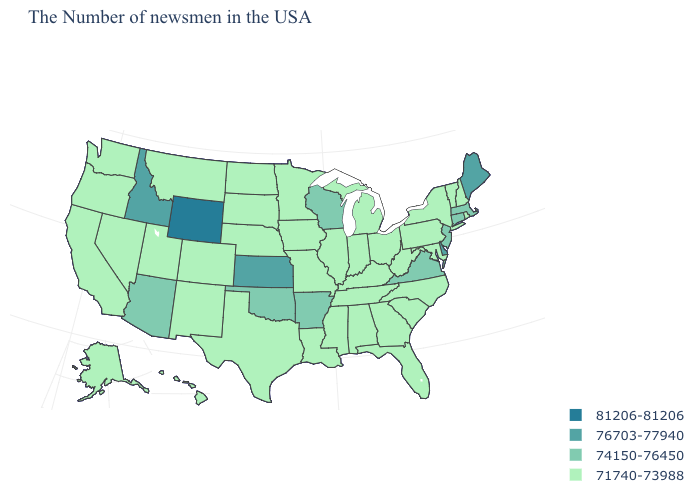Which states have the highest value in the USA?
Answer briefly. Wyoming. Does the map have missing data?
Write a very short answer. No. What is the value of Georgia?
Concise answer only. 71740-73988. Name the states that have a value in the range 76703-77940?
Quick response, please. Maine, Delaware, Kansas, Idaho. What is the value of Massachusetts?
Concise answer only. 74150-76450. Does South Dakota have a lower value than Alabama?
Quick response, please. No. What is the value of North Carolina?
Answer briefly. 71740-73988. Name the states that have a value in the range 81206-81206?
Concise answer only. Wyoming. Name the states that have a value in the range 76703-77940?
Answer briefly. Maine, Delaware, Kansas, Idaho. Name the states that have a value in the range 81206-81206?
Answer briefly. Wyoming. What is the value of Texas?
Give a very brief answer. 71740-73988. Does Wyoming have the highest value in the West?
Concise answer only. Yes. What is the highest value in the USA?
Answer briefly. 81206-81206. 